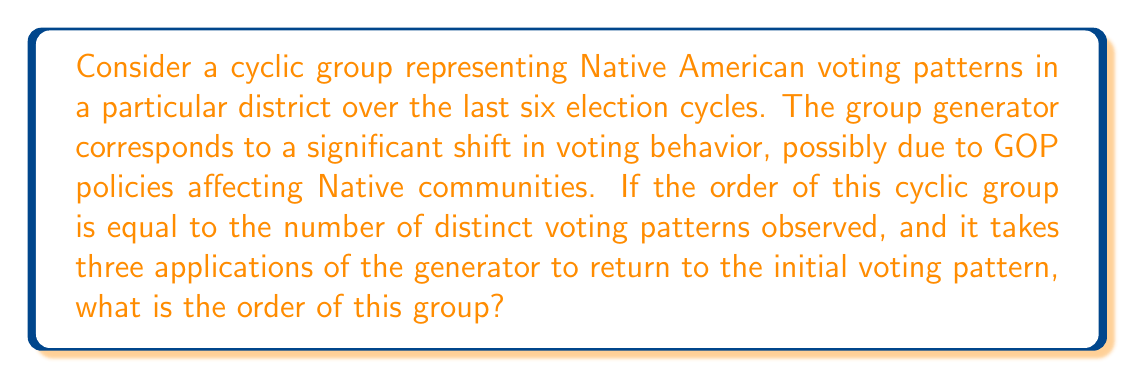Solve this math problem. Let's approach this step-by-step:

1) In a cyclic group, the order of the group is equal to the order of its generator. Let's call our generator $g$.

2) We're told that it takes three applications of the generator to return to the initial voting pattern. This means:

   $g^3 = e$ (where $e$ is the identity element)

3) In group theory, this implies that the order of $g$ divides 3. The possible orders are therefore 1 or 3.

4) However, the order cannot be 1, because that would mean $g = e$, which doesn't represent any change in voting pattern.

5) Therefore, the order of the generator $g$ must be 3.

6) In a cyclic group, each application of the generator produces a unique element until we cycle back to the identity. So the elements of this group are:

   $\{e, g, g^2\}$

7) This corresponds to three distinct voting patterns:
   - The initial pattern ($e$)
   - The pattern after one shift ($g$)
   - The pattern after two shifts ($g^2$)

8) We're told that the order of the group is equal to the number of distinct voting patterns observed. We've identified 3 distinct patterns.

Therefore, the order of this cyclic group is 3.
Answer: The order of the cyclic group is 3. 